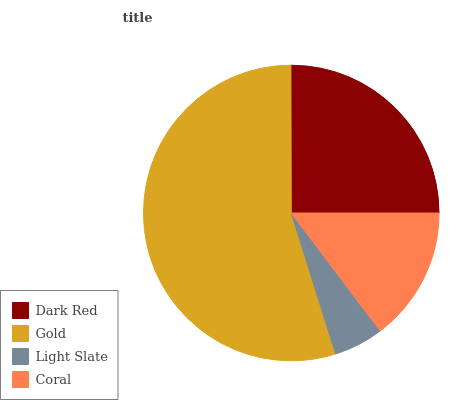Is Light Slate the minimum?
Answer yes or no. Yes. Is Gold the maximum?
Answer yes or no. Yes. Is Gold the minimum?
Answer yes or no. No. Is Light Slate the maximum?
Answer yes or no. No. Is Gold greater than Light Slate?
Answer yes or no. Yes. Is Light Slate less than Gold?
Answer yes or no. Yes. Is Light Slate greater than Gold?
Answer yes or no. No. Is Gold less than Light Slate?
Answer yes or no. No. Is Dark Red the high median?
Answer yes or no. Yes. Is Coral the low median?
Answer yes or no. Yes. Is Gold the high median?
Answer yes or no. No. Is Light Slate the low median?
Answer yes or no. No. 